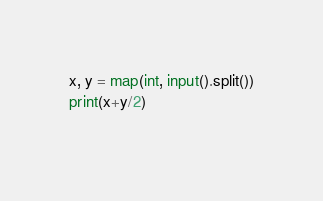<code> <loc_0><loc_0><loc_500><loc_500><_Python_>x, y = map(int, input().split())
print(x+y/2)
  </code> 